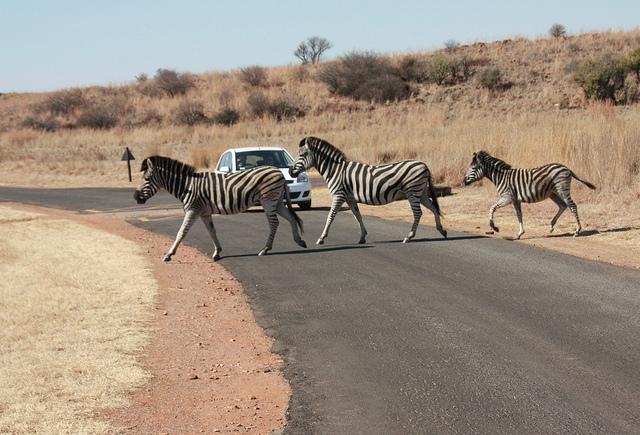How many animals are crossing the road?
Quick response, please. 3. Is the car moving?
Be succinct. No. What shape is the background sign?
Quick response, please. Triangle. 